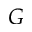Convert formula to latex. <formula><loc_0><loc_0><loc_500><loc_500>G</formula> 